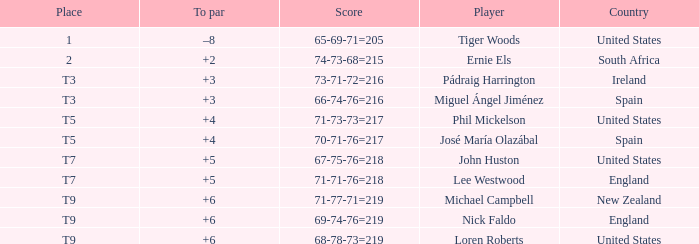What is Country, when Place is "T9", and when Player is "Michael Campbell"? New Zealand. 